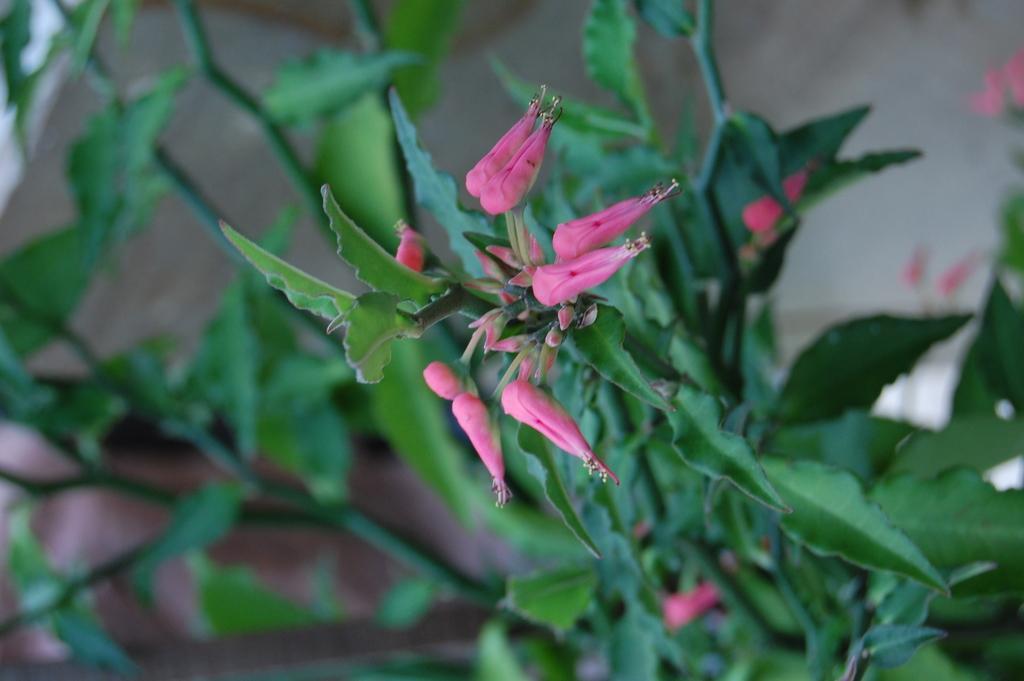Could you give a brief overview of what you see in this image? In this image there are plants and we can see flowers. 